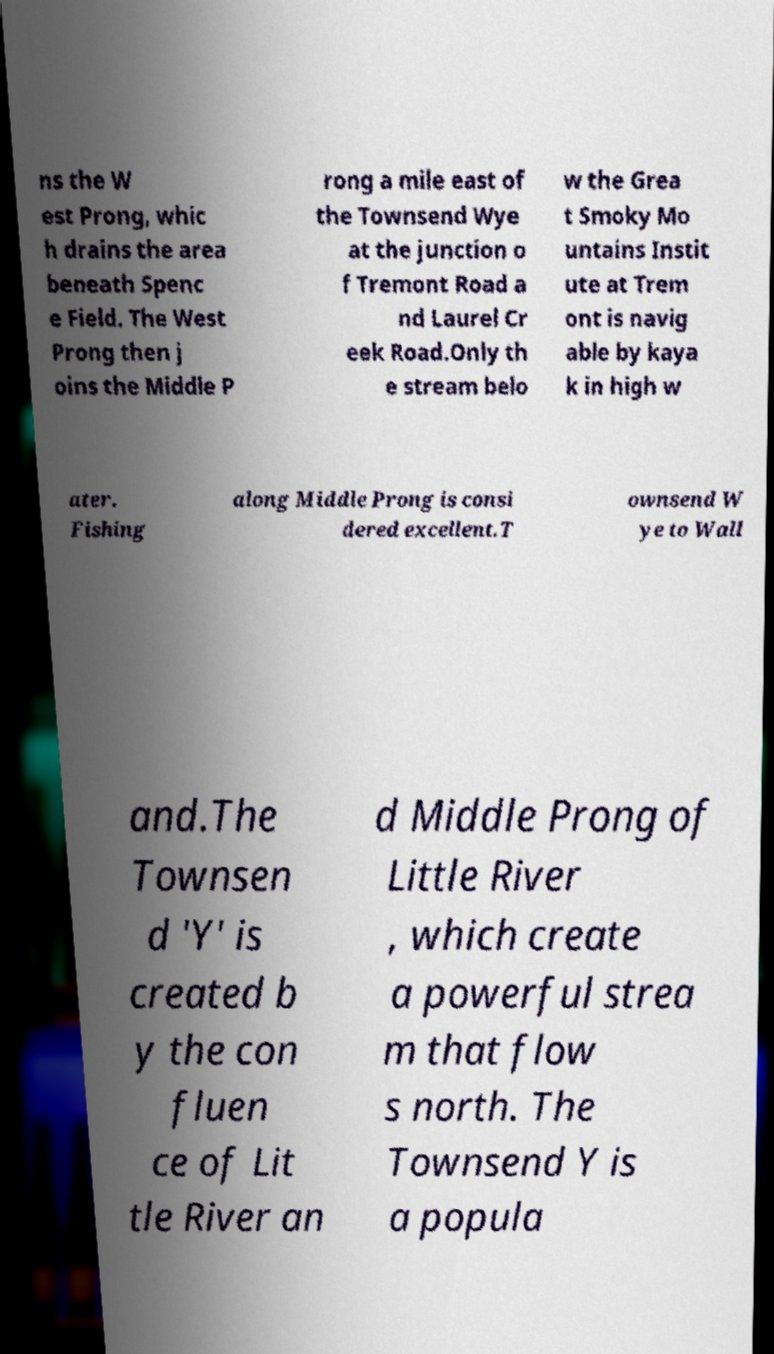Please identify and transcribe the text found in this image. ns the W est Prong, whic h drains the area beneath Spenc e Field. The West Prong then j oins the Middle P rong a mile east of the Townsend Wye at the junction o f Tremont Road a nd Laurel Cr eek Road.Only th e stream belo w the Grea t Smoky Mo untains Instit ute at Trem ont is navig able by kaya k in high w ater. Fishing along Middle Prong is consi dered excellent.T ownsend W ye to Wall and.The Townsen d 'Y' is created b y the con fluen ce of Lit tle River an d Middle Prong of Little River , which create a powerful strea m that flow s north. The Townsend Y is a popula 